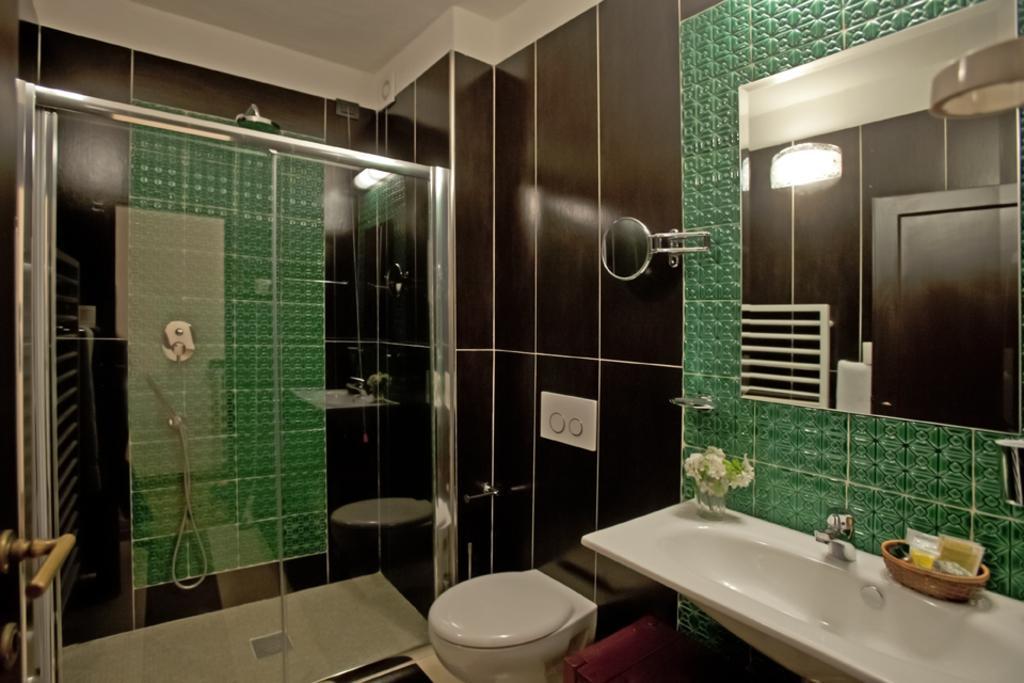Describe this image in one or two sentences. On the right side there is a wall. On the wall there is a mirror. On the mirror there is a reflection of light and door. Near to that there is a wash basin with a tap. On that there is a basket with some items and a vase with flowers. Near to that there is a flush. There is glass wall. On the left side there is a handle. In the back there is a shower. 